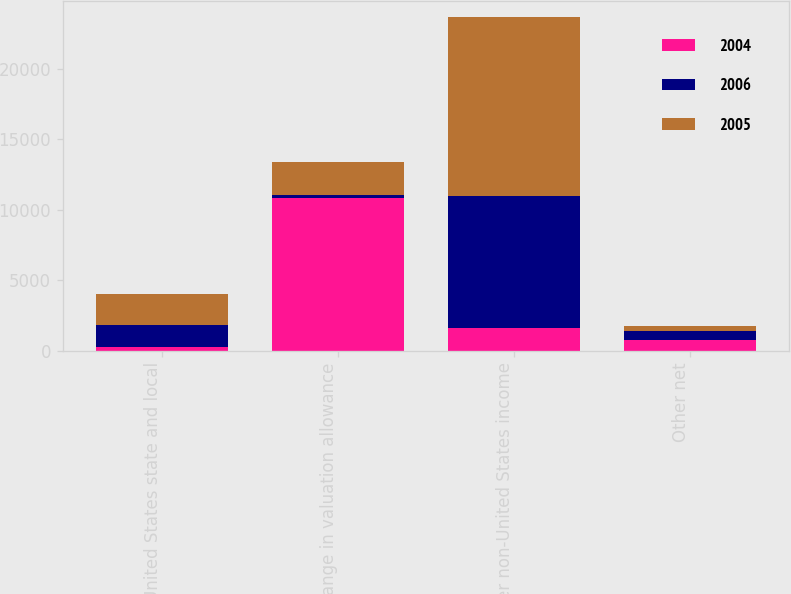Convert chart. <chart><loc_0><loc_0><loc_500><loc_500><stacked_bar_chart><ecel><fcel>United States state and local<fcel>Change in valuation allowance<fcel>Other non-United States income<fcel>Other net<nl><fcel>2004<fcel>247<fcel>10860<fcel>1574<fcel>712<nl><fcel>2006<fcel>1574<fcel>160<fcel>9428<fcel>649<nl><fcel>2005<fcel>2165<fcel>2375<fcel>12646<fcel>395<nl></chart> 